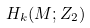<formula> <loc_0><loc_0><loc_500><loc_500>H _ { k } ( M ; Z _ { 2 } )</formula> 